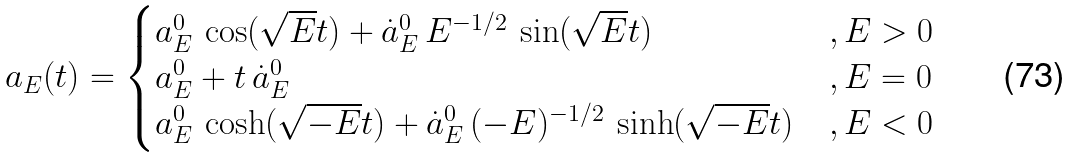<formula> <loc_0><loc_0><loc_500><loc_500>a _ { E } ( t ) = \begin{cases} a _ { E } ^ { 0 } \, \cos ( \sqrt { E } t ) + \dot { a } _ { E } ^ { 0 } \, E ^ { - 1 / 2 } \, \sin ( \sqrt { E } t ) \ & , E > 0 \\ a _ { E } ^ { 0 } + t \, \dot { a } _ { E } ^ { 0 } & , E = 0 \\ a _ { E } ^ { 0 } \, \cosh ( \sqrt { - E } t ) + \dot { a } _ { E } ^ { 0 } \, ( - E ) ^ { - 1 / 2 } \, \sinh ( \sqrt { - E } t ) & , E < 0 \end{cases}</formula> 